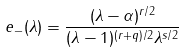<formula> <loc_0><loc_0><loc_500><loc_500>e _ { - } ( \lambda ) = \frac { ( \lambda - \alpha ) ^ { r / 2 } } { ( \lambda - 1 ) ^ { ( r + q ) / 2 } \lambda ^ { s / 2 } }</formula> 